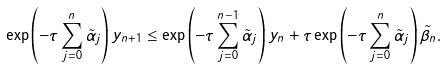Convert formula to latex. <formula><loc_0><loc_0><loc_500><loc_500>\exp \left ( { - \tau \sum _ { j = 0 } ^ { n } \tilde { \alpha } _ { j } } \right ) y _ { n + 1 } \leq \exp \left ( { - \tau \sum _ { j = 0 } ^ { n - 1 } \tilde { \alpha } _ { j } } \right ) y _ { n } + \tau \exp \left ( { - \tau \sum _ { j = 0 } ^ { n } \tilde { \alpha } _ { j } } \right ) \tilde { \beta } _ { n } .</formula> 